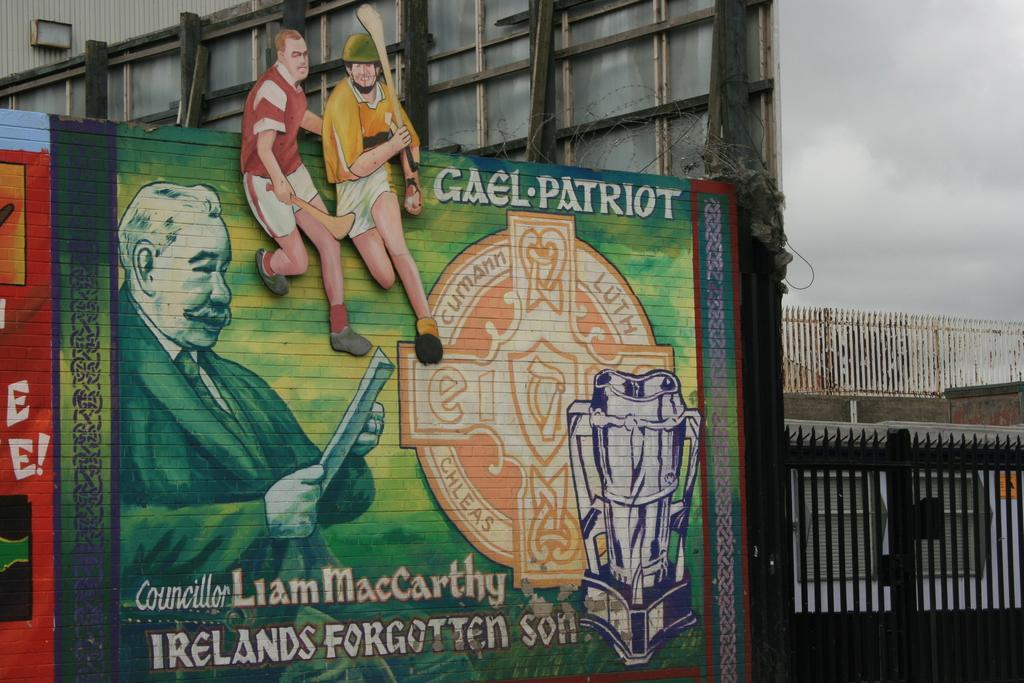<image>
Present a compact description of the photo's key features. Wall with drawing of grafitti and the words "Irelands Forgotten Son". 